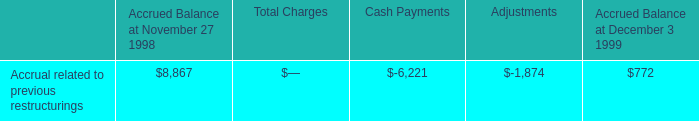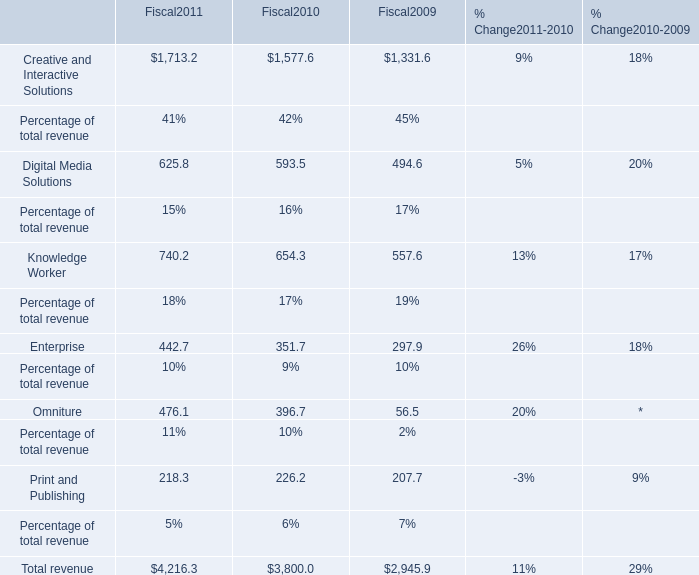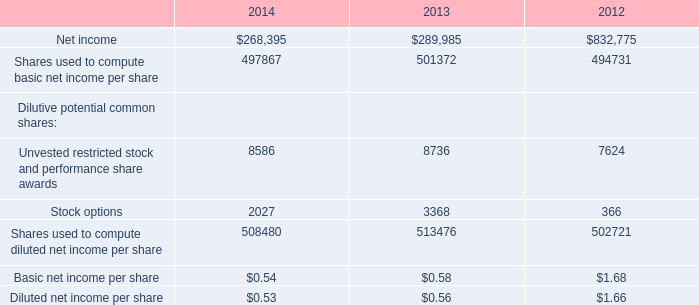What is the growing rate of Knowledge Worker in the years with the least Enterprise? (in %) 
Computations: (557.6 / ((740.2 + 654.3) + 557.6))
Answer: 0.28564. 